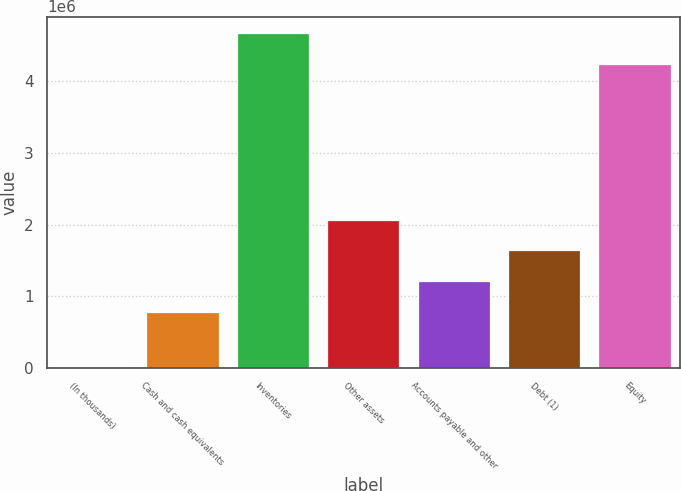<chart> <loc_0><loc_0><loc_500><loc_500><bar_chart><fcel>(In thousands)<fcel>Cash and cash equivalents<fcel>Inventories<fcel>Other assets<fcel>Accounts payable and other<fcel>Debt (1)<fcel>Equity<nl><fcel>2018<fcel>782565<fcel>4.66721e+06<fcel>2.0694e+06<fcel>1.21151e+06<fcel>1.64046e+06<fcel>4.23826e+06<nl></chart> 